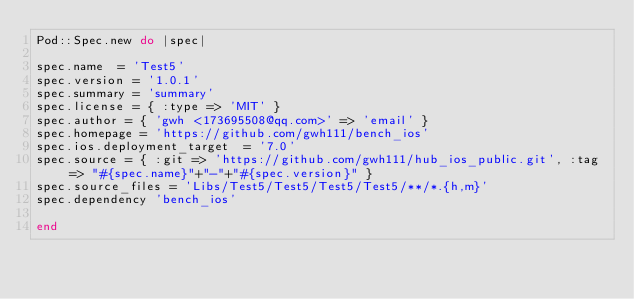<code> <loc_0><loc_0><loc_500><loc_500><_Ruby_>Pod::Spec.new do |spec|

spec.name  = 'Test5'
spec.version = '1.0.1'
spec.summary = 'summary'
spec.license = { :type => 'MIT' }
spec.author = { 'gwh <173695508@qq.com>' => 'email' }
spec.homepage = 'https://github.com/gwh111/bench_ios'
spec.ios.deployment_target  = '7.0'
spec.source = { :git => 'https://github.com/gwh111/hub_ios_public.git', :tag => "#{spec.name}"+"-"+"#{spec.version}" }
spec.source_files = 'Libs/Test5/Test5/Test5/Test5/**/*.{h,m}'
spec.dependency 'bench_ios'

end
</code> 